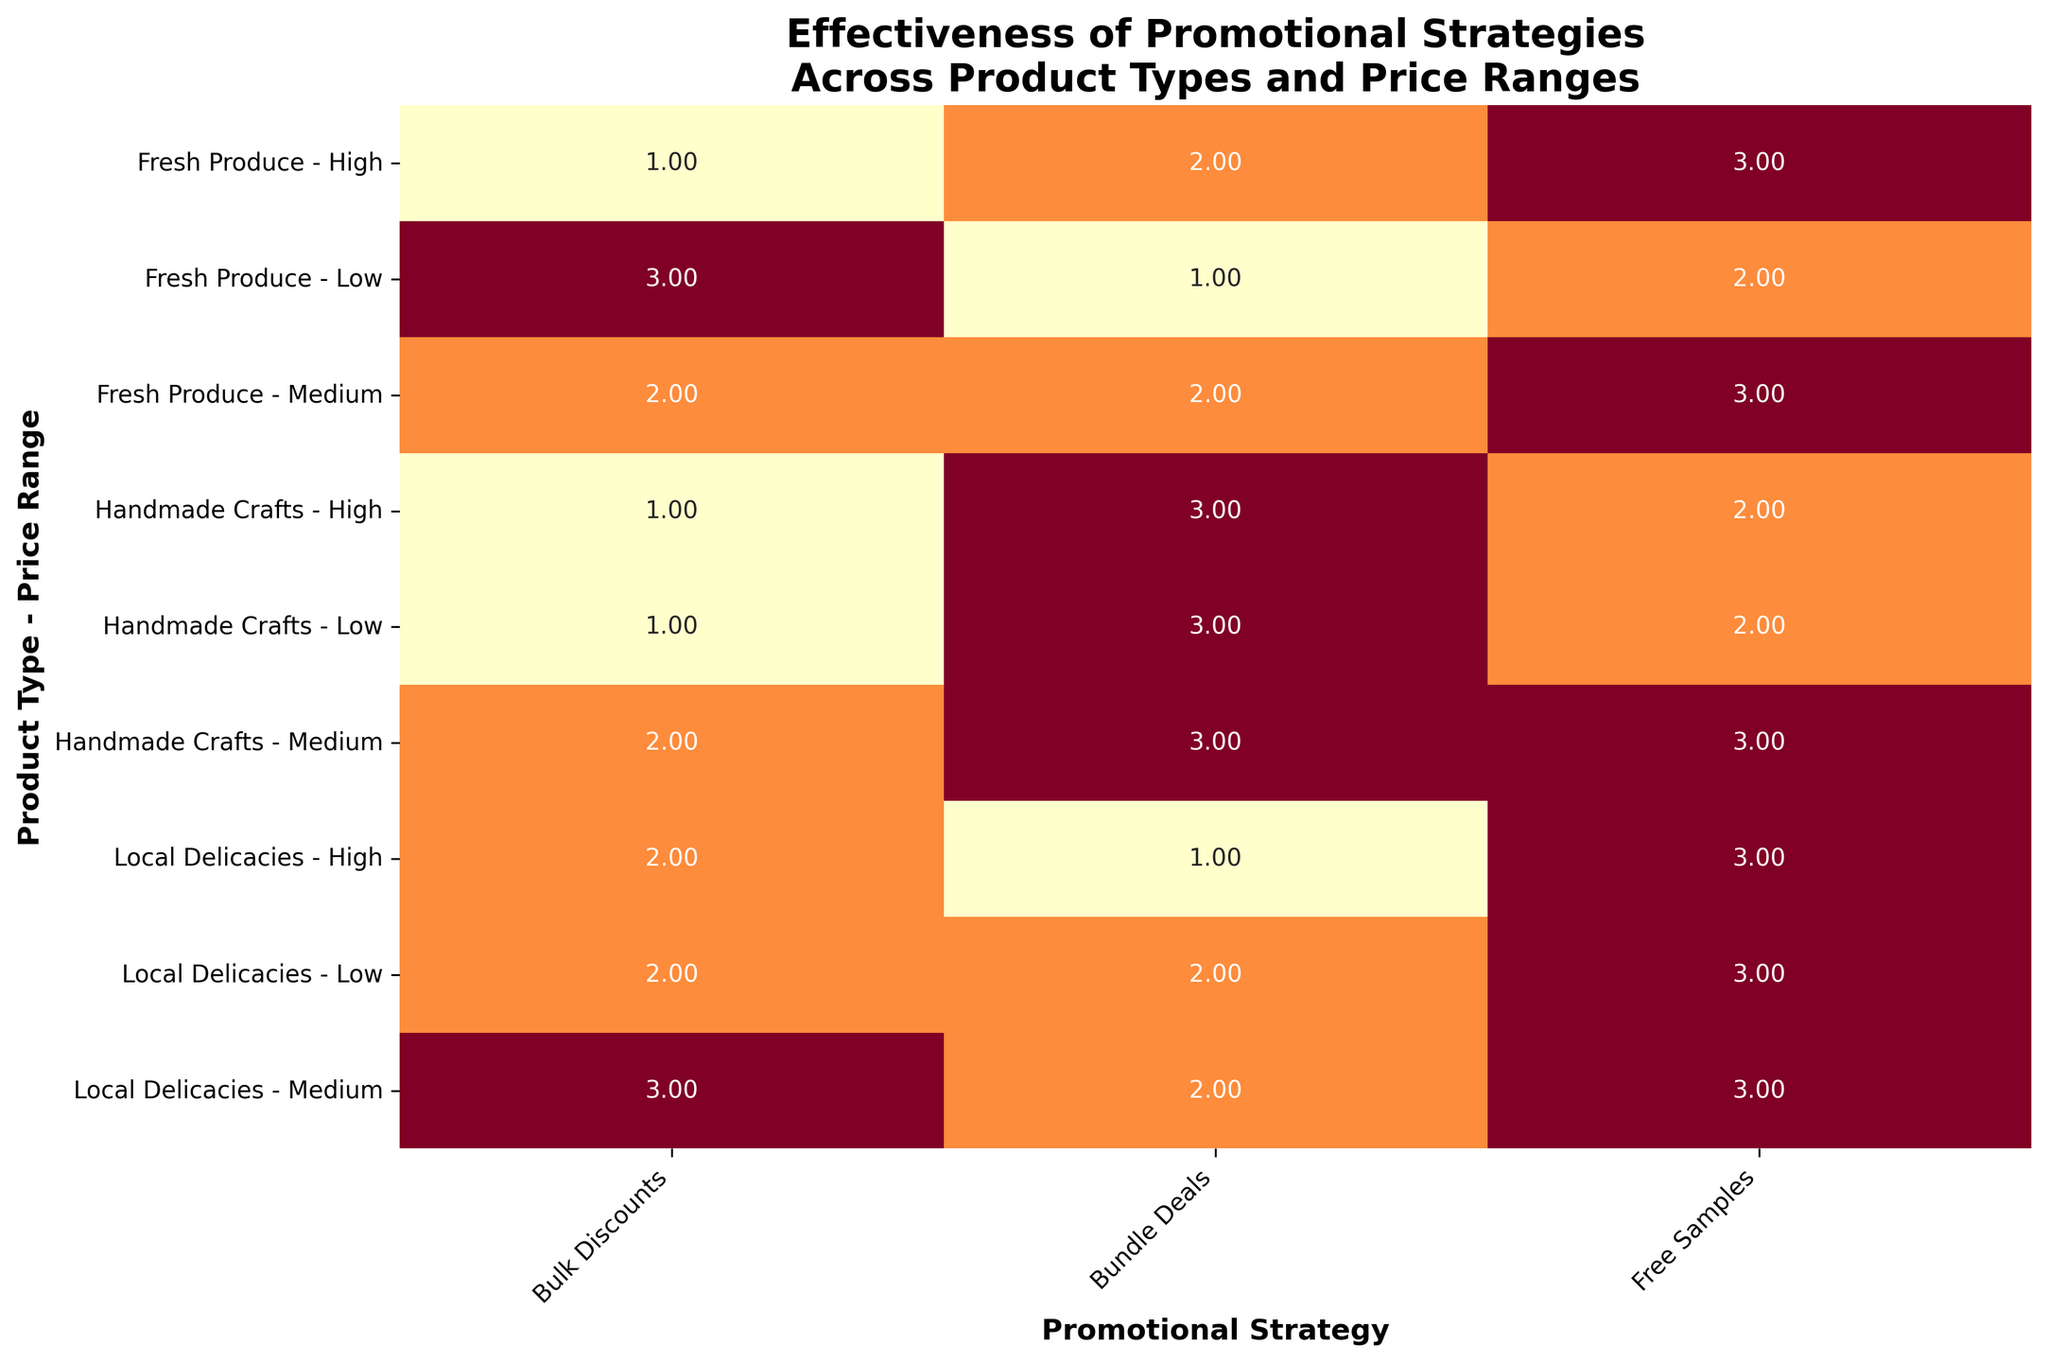What is the most effective promotional strategy for Fresh Produce with a medium price range? First, find the row corresponding to "Fresh Produce - Medium" on the y-axis. Within this row, locate the highest value, which represents the highest effectiveness score. This value is under the "Free Samples" column.
Answer: Free Samples Which product type and price range combination has the lowest effectiveness score for Bulk Discounts? Look at all rows under the "Bulk Discounts" column to identify the lowest value. The lowest effectiveness score of 1 can be found in two rows: "Fresh Produce - High" and "Handmade Crafts - Low." Choose one combination, for instance, "Fresh Produce - High." Then validate if another product type and price range also has the same score.
Answer: Fresh Produce - High or Handmade Crafts - Low For Handmade Crafts, how does the effectiveness of Bundle Deals compare across different price ranges? Focus on the rows containing "Handmade Crafts" and examine the "Bundle Deals" column for each price range. "Handmade Crafts - Low" has a score of 3, "Handmade Crafts - Medium" has 3, and "Handmade Crafts - High" also has 3, indicating the effectiveness score is consistently high across all price ranges.
Answer: Consistently high What is the average effectiveness score of promotional strategies for Local Delicacies with medium price range? Identify the row for "Local Delicacies - Medium." The scores are 3 (Bulk Discounts), 3 (Free Samples), and 2 (Bundle Deals). Calculate the average of these values: (3+3+2)/3 = 8/3 ≈ 2.67.
Answer: Approximately 2.67 Which promotional strategy has the highest effectiveness for high-priced items across all product types? Examine the rows under "High" on the y-axis for all product types. Identify the highest scores in these rows. Fresh Produce has 3 for Free Samples, Handmade Crafts has 3 for Bundle Deals, and Local Delicacies has 3 for Free Samples. Since two promotional strategies have a score of 3, pick one.
Answer: Free Samples or Bundle Deals What is the least effective promotional strategy for Fresh Produce at low price range? Look at the row for "Fresh Produce - Low" on the y-axis. Identify the lowest value in this row. The score for Bundle Deals is the lowest, which is 1.
Answer: Bundle Deals For which product type and price range is the effectiveness of Free Samples the same as Bulk Discounts? Compare the values in the "Free Samples" and "Bulk Discounts" columns for each product type and price range. Look for rows where these columns have the same score. The "Local Delicacies - Medium" row has a score of 3 in both columns.
Answer: Local Delicacies - Medium How does the effectiveness of Bundle Deals differ between Handmade Crafts and Local Delicacies for high price ranges? Find the rows for "Handmade Crafts - High" and "Local Delicacies - High" and compare the scores in the "Bundle Deals" column. Handmade Crafts has a score of 3, while Local Delicacies has a score of 1, showing a difference of 2.
Answer: Higher for Handmade Crafts by 2 Which product type benefits most from Bulk Discounts in the medium price range? Focus on the "Bulk Discounts" column and identify the highest score in the rows under "Medium." The highest score is found in the "Local Delicacies - Medium" row with a score of 3 compared to the other medium-priced products.
Answer: Local Delicacies 